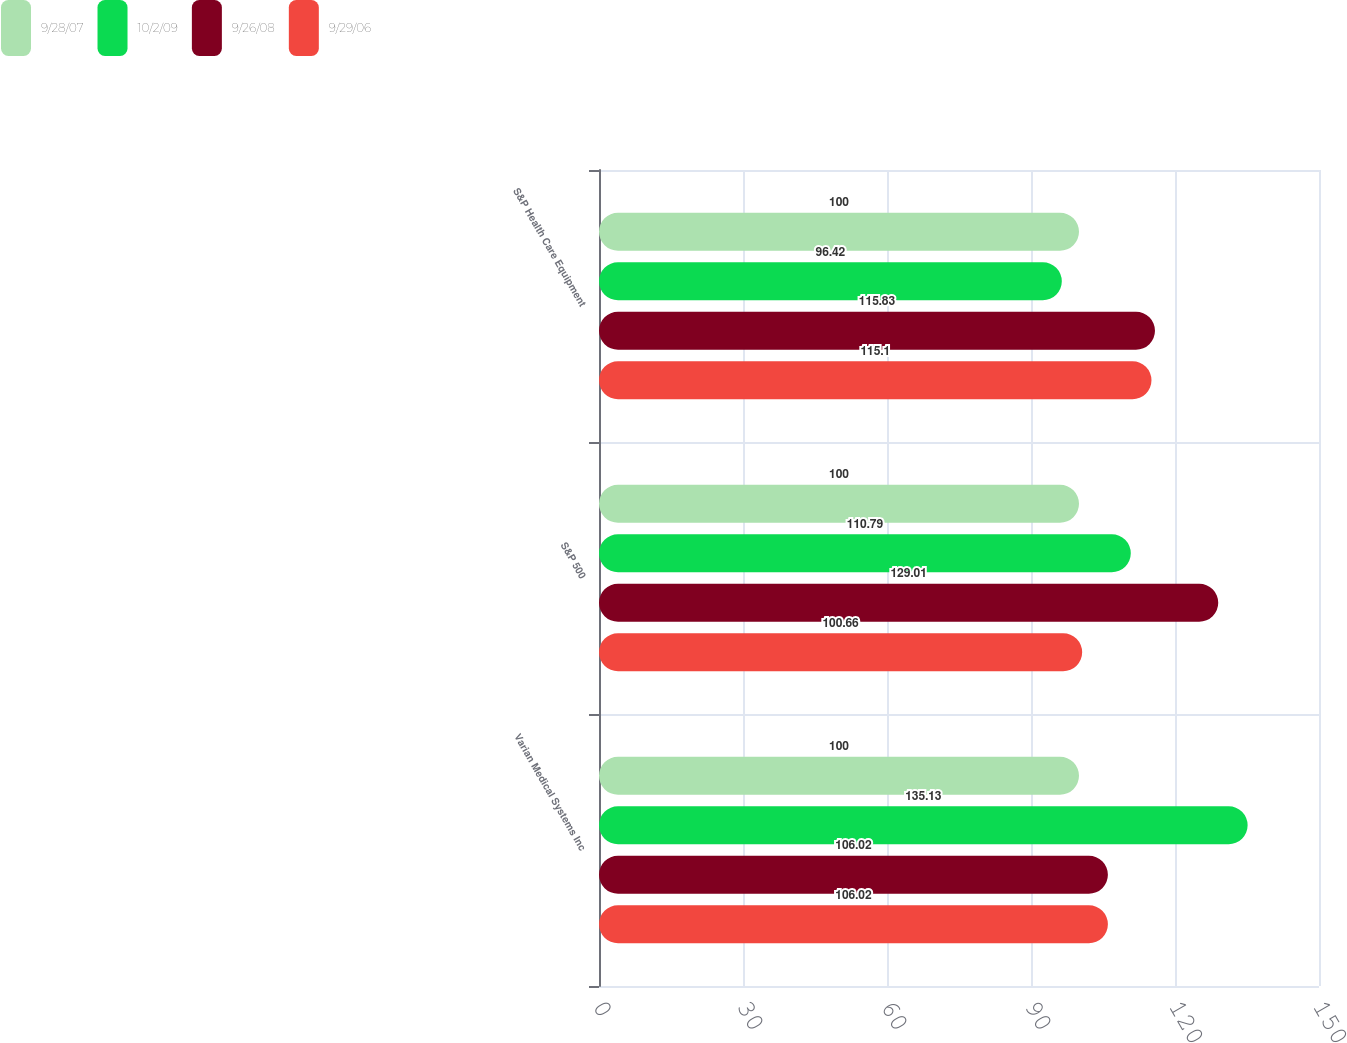<chart> <loc_0><loc_0><loc_500><loc_500><stacked_bar_chart><ecel><fcel>Varian Medical Systems Inc<fcel>S&P 500<fcel>S&P Health Care Equipment<nl><fcel>9/28/07<fcel>100<fcel>100<fcel>100<nl><fcel>10/2/09<fcel>135.13<fcel>110.79<fcel>96.42<nl><fcel>9/26/08<fcel>106.02<fcel>129.01<fcel>115.83<nl><fcel>9/29/06<fcel>106.02<fcel>100.66<fcel>115.1<nl></chart> 